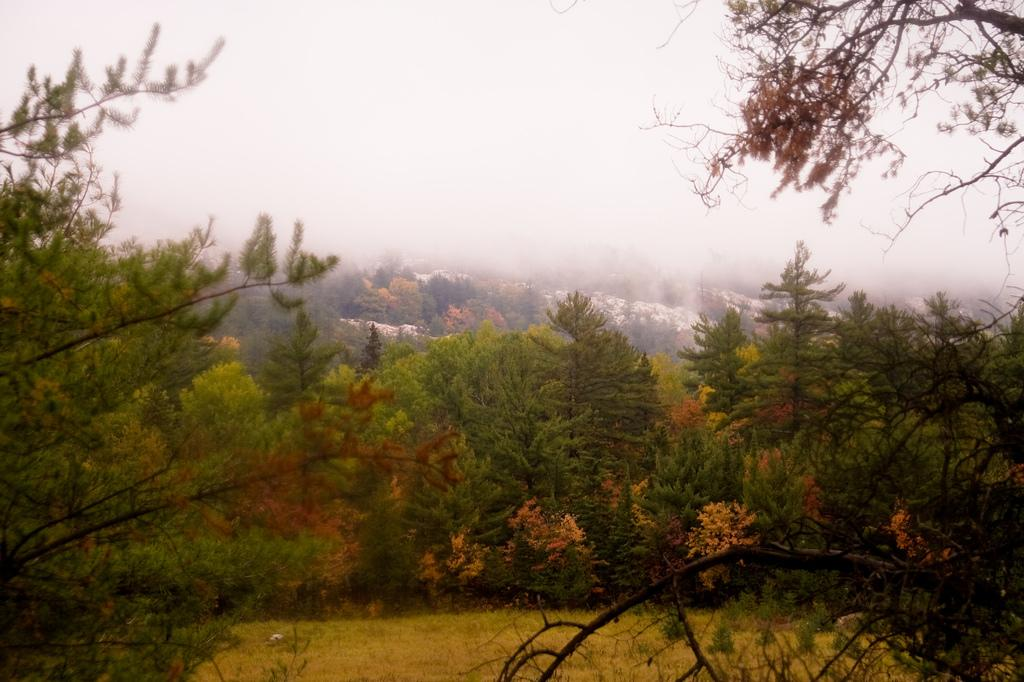What type of vegetation is in the center of the image? There are trees in the center of the image. What type of ground cover is at the bottom of the image? There is grass at the bottom of the image. What part of the natural environment is visible at the top of the image? The sky is visible at the top of the image. What kind of trouble is the partner experiencing in the image? There is no partner or any indication of trouble present in the image. 